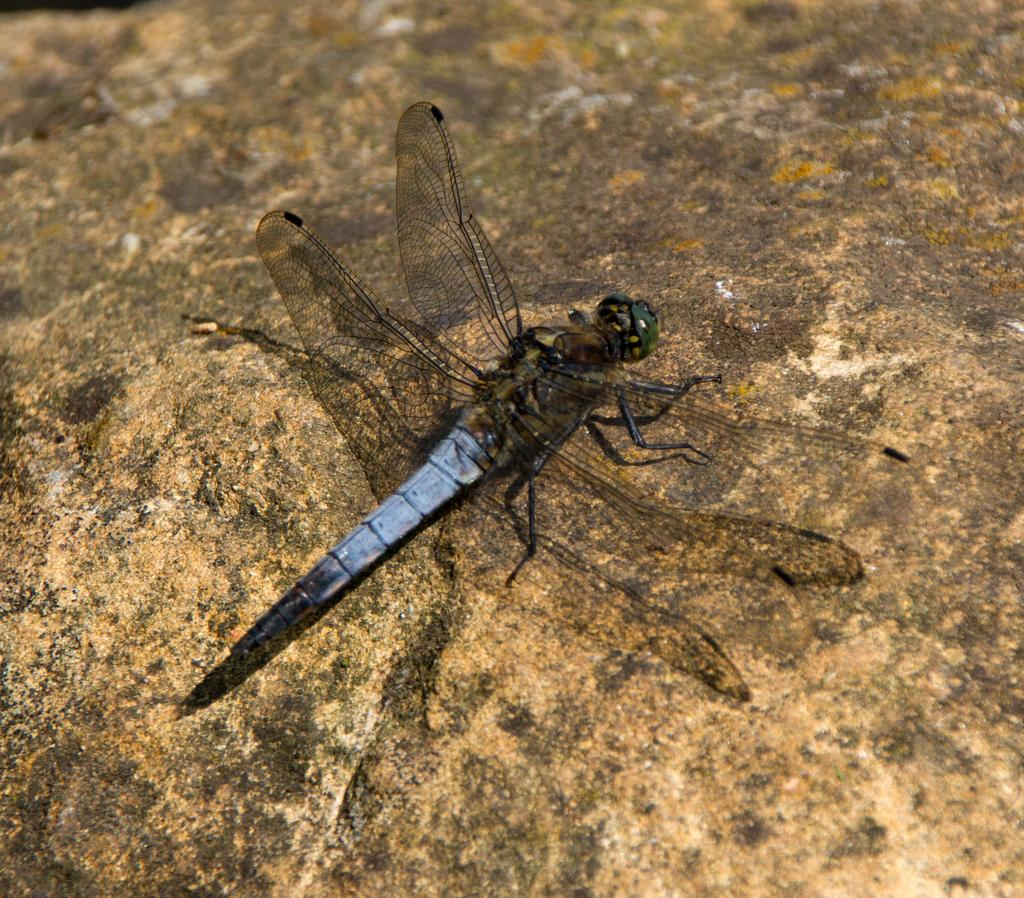What type of insect is in the image? There is a dragonfly in the image. Where is the dragonfly located? The dragonfly is on a rock. What is the chance of a rainstorm occurring in the image? There is no indication of a rainstorm in the image, as it only features a dragonfly on a rock. 